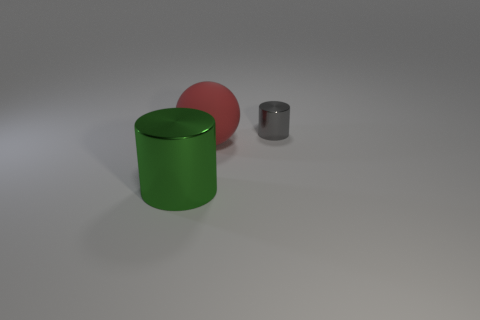What can you infer about the setting this image might be portraying? The image appears to be set in a simplistic and nondescript environment with a neutral background. It might be portraying a controlled setting such as a studio for product photography or a 3D modeling environment. 